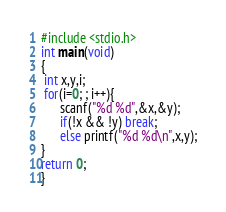<code> <loc_0><loc_0><loc_500><loc_500><_C_>#include <stdio.h>
int main(void)
{
 int x,y,i;
 for(i=0; ; i++){
      scanf("%d %d",&x,&y);
      if(!x && !y) break;
      else printf("%d %d\n",x,y);
}
return 0;
}</code> 